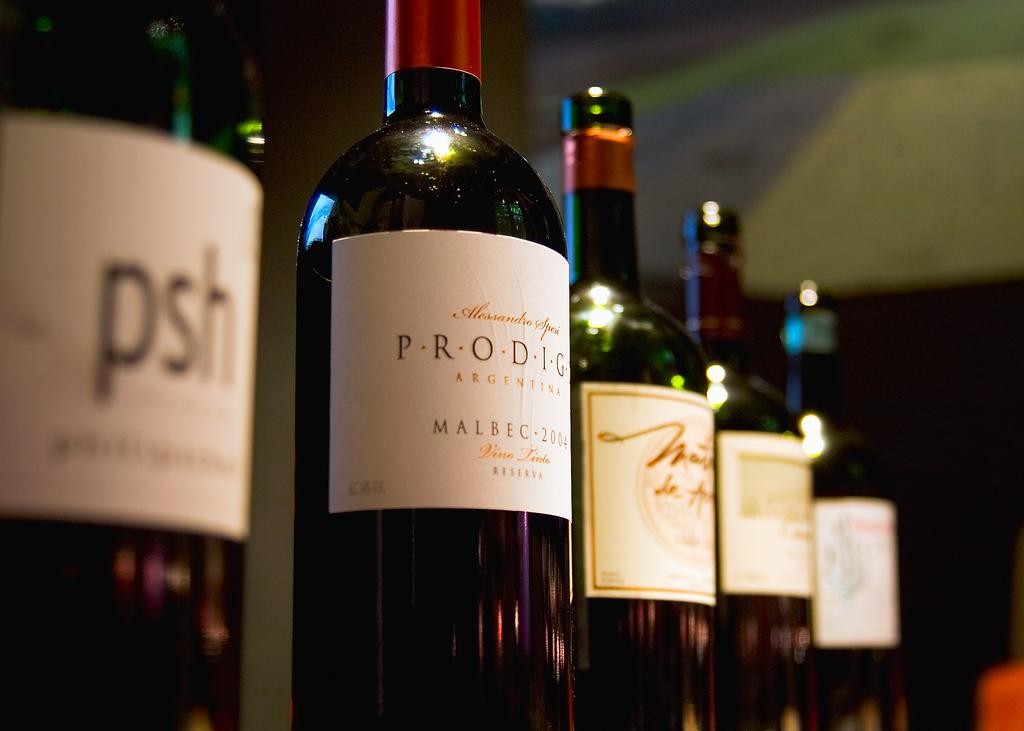<image>
Share a concise interpretation of the image provided. A bottle of wine called psh sits at the very front of the photo. 